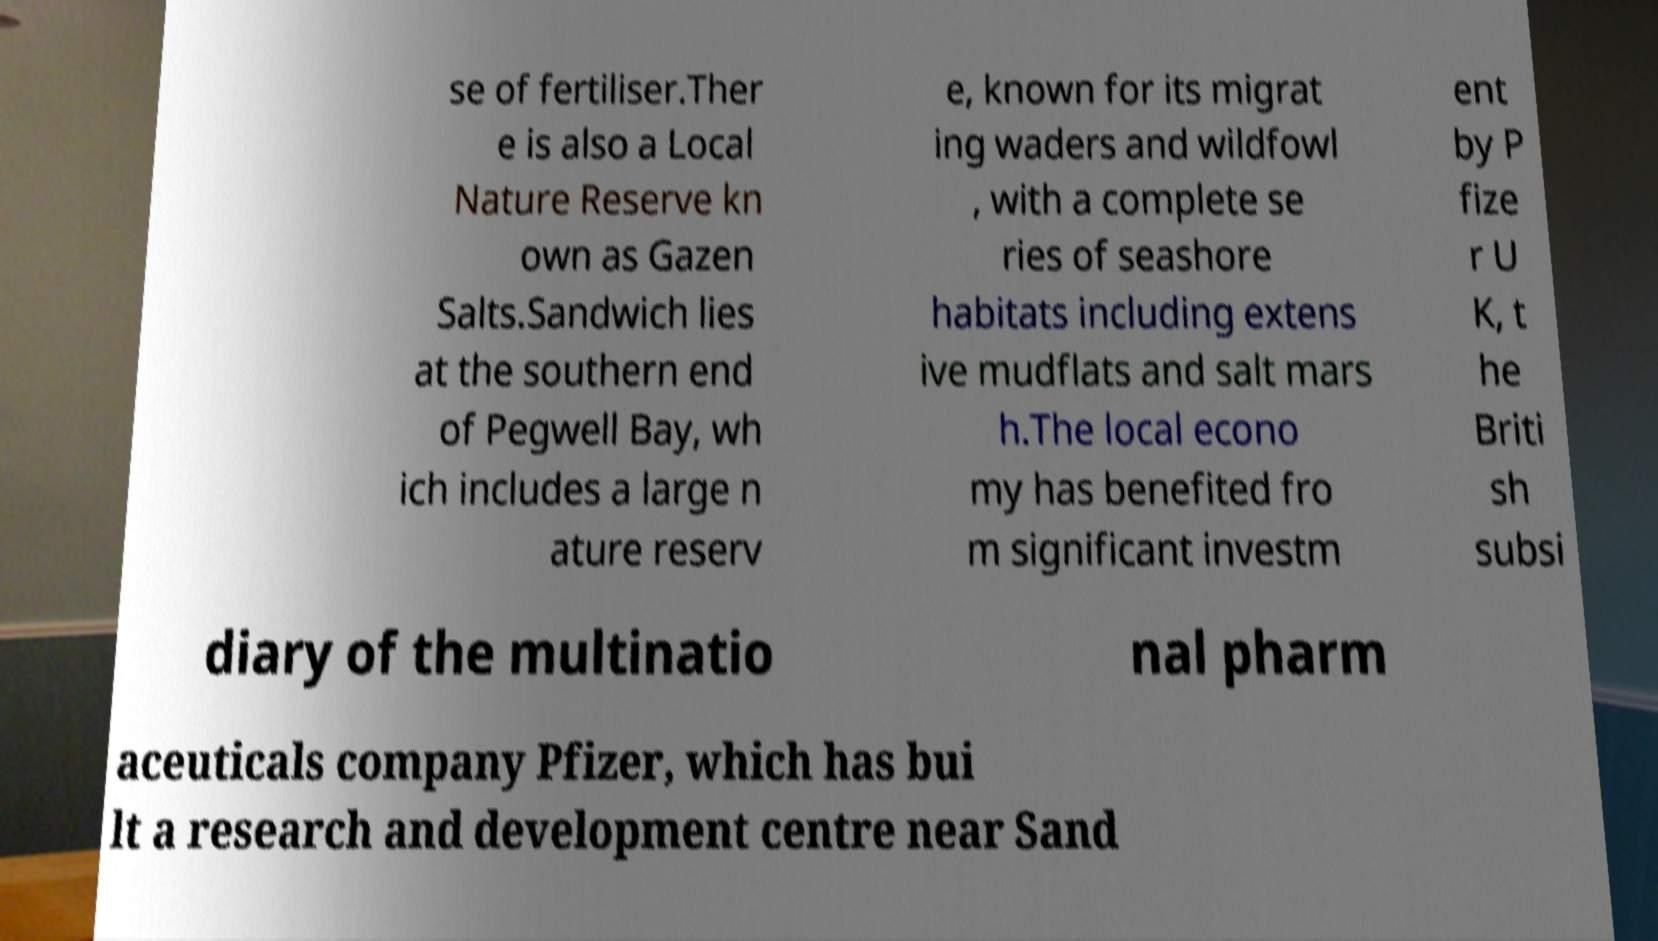Can you accurately transcribe the text from the provided image for me? se of fertiliser.Ther e is also a Local Nature Reserve kn own as Gazen Salts.Sandwich lies at the southern end of Pegwell Bay, wh ich includes a large n ature reserv e, known for its migrat ing waders and wildfowl , with a complete se ries of seashore habitats including extens ive mudflats and salt mars h.The local econo my has benefited fro m significant investm ent by P fize r U K, t he Briti sh subsi diary of the multinatio nal pharm aceuticals company Pfizer, which has bui lt a research and development centre near Sand 